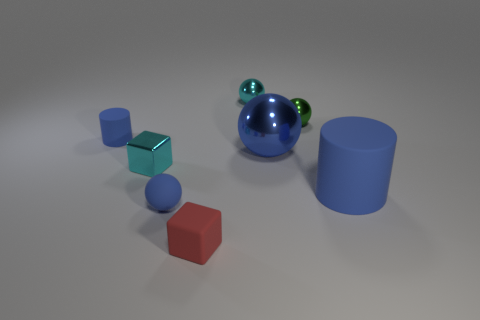Add 1 tiny green things. How many objects exist? 9 Subtract all large metallic balls. How many balls are left? 3 Subtract all blue spheres. How many spheres are left? 2 Subtract all cylinders. How many objects are left? 6 Subtract all gray cylinders. How many blue balls are left? 2 Add 3 blue metallic balls. How many blue metallic balls are left? 4 Add 4 tiny green matte things. How many tiny green matte things exist? 4 Subtract 0 green cylinders. How many objects are left? 8 Subtract 1 balls. How many balls are left? 3 Subtract all gray cylinders. Subtract all blue blocks. How many cylinders are left? 2 